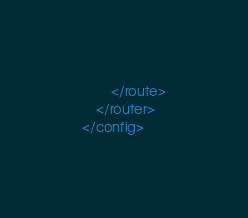Convert code to text. <code><loc_0><loc_0><loc_500><loc_500><_XML_>		</route>
	</router>
</config></code> 